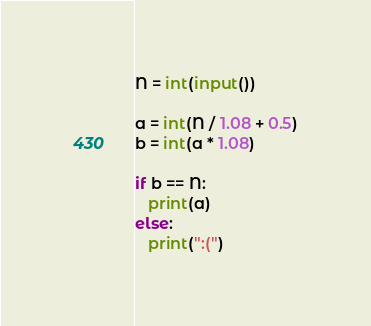Convert code to text. <code><loc_0><loc_0><loc_500><loc_500><_Python_>N = int(input())

a = int(N / 1.08 + 0.5)
b = int(a * 1.08)

if b == N:
   print(a)
else:
   print(":(")</code> 